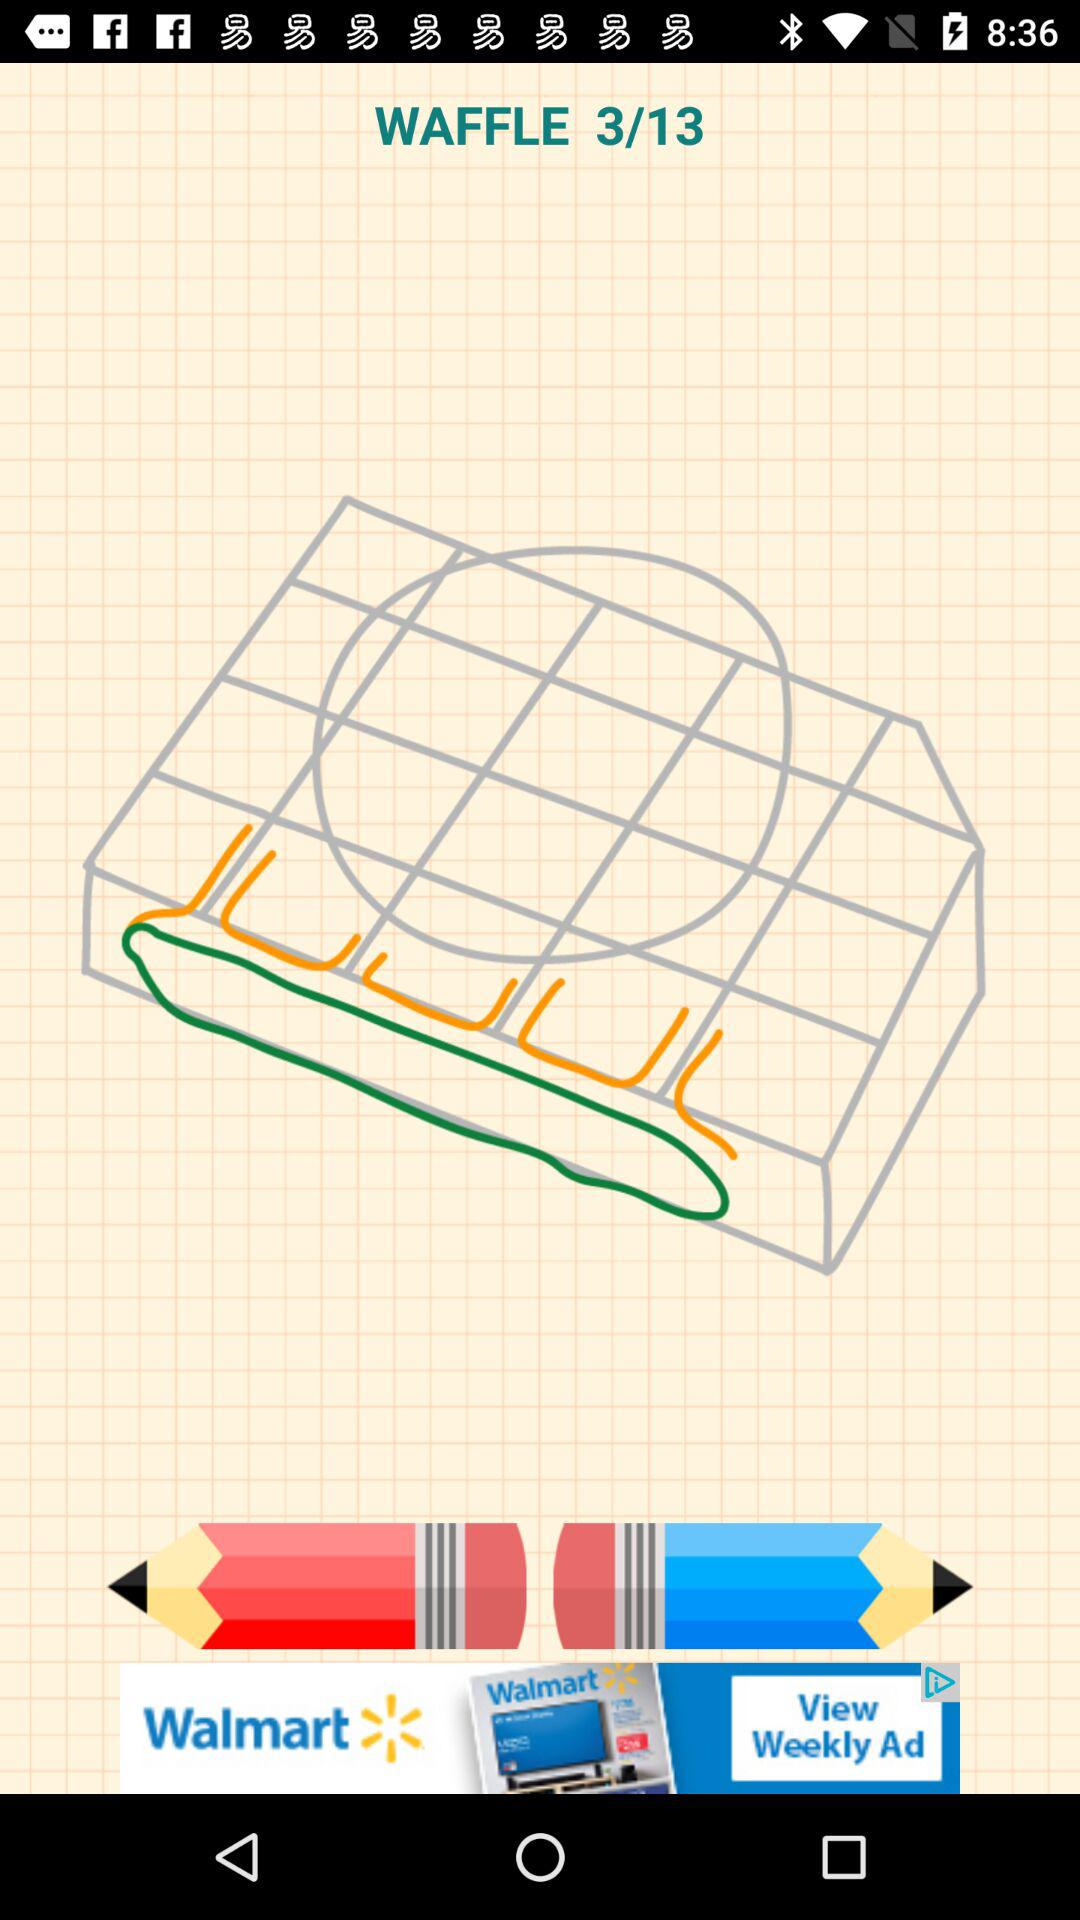How many steps of waffle are available in total? There are 13 steps in total. 